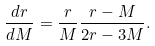Convert formula to latex. <formula><loc_0><loc_0><loc_500><loc_500>\frac { d r } { d M } = \frac { r } { M } \frac { r - M } { 2 r - 3 M } .</formula> 